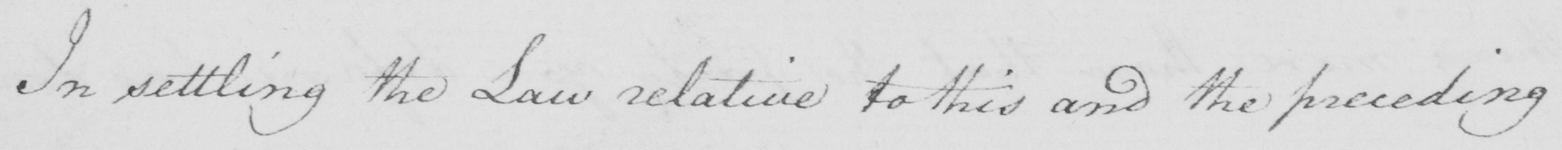Transcribe the text shown in this historical manuscript line. In settling the Law relative to this and the preceding 